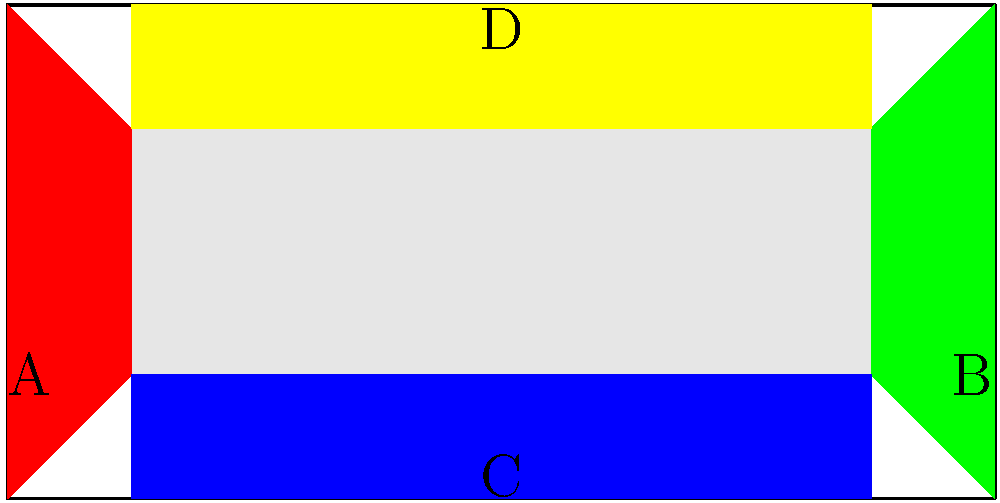The architectural blueprint shows a stadium expansion plan. The existing stands are represented by the gray area, while the colored areas represent potential expansion zones. If the club decides to expand the stadium capacity by adding new stands in two adjacent areas, how many unique combinations of expansion are possible? To solve this problem, let's follow these steps:

1. Identify the expansion areas:
   A (red), B (green), C (blue), and D (yellow)

2. List all possible pairs of adjacent areas:
   - A and C
   - A and D
   - B and C
   - B and D

3. Count the number of unique combinations:
   There are 4 unique combinations of adjacent areas.

4. Consider the group theory aspect:
   In group theory, this problem can be viewed as a combination problem on a cyclic group of order 4. The stadium's layout forms a cycle (A-C-B-D-A), and we're selecting 2 adjacent elements from this cycle.

5. Verify the result:
   In a cyclic group of order n, the number of ways to select k adjacent elements is always equal to n, regardless of k (as long as k ≤ n). In this case, n = 4 (four expansion areas) and k = 2 (two adjacent areas), so the result is 4.

Therefore, there are 4 unique combinations of expansion possible by adding new stands in two adjacent areas.
Answer: 4 combinations 